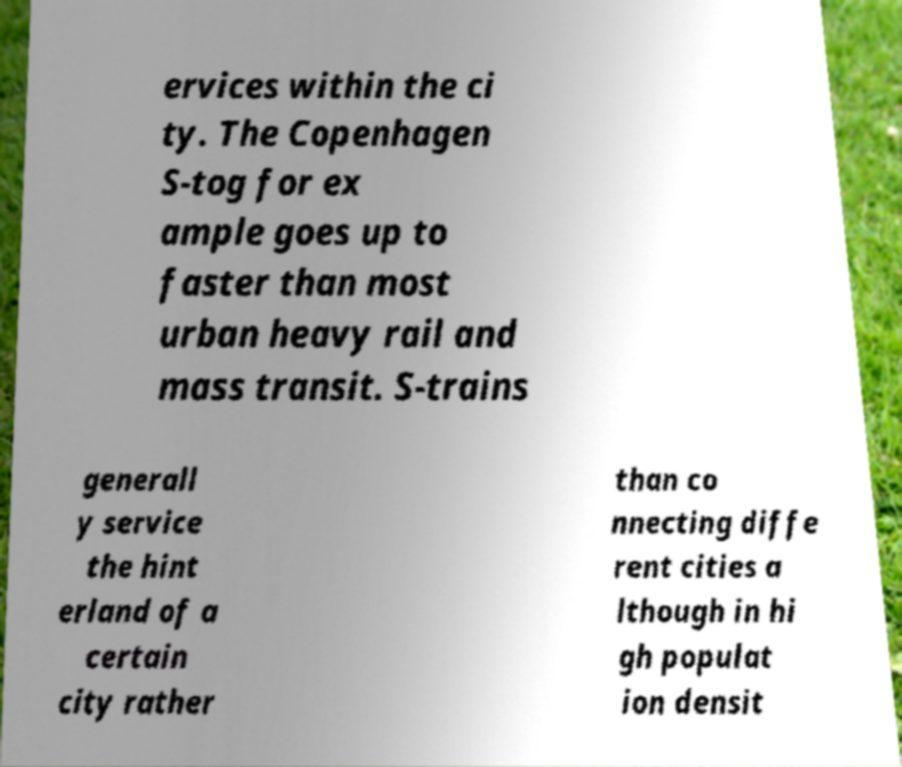Please identify and transcribe the text found in this image. ervices within the ci ty. The Copenhagen S-tog for ex ample goes up to faster than most urban heavy rail and mass transit. S-trains generall y service the hint erland of a certain city rather than co nnecting diffe rent cities a lthough in hi gh populat ion densit 